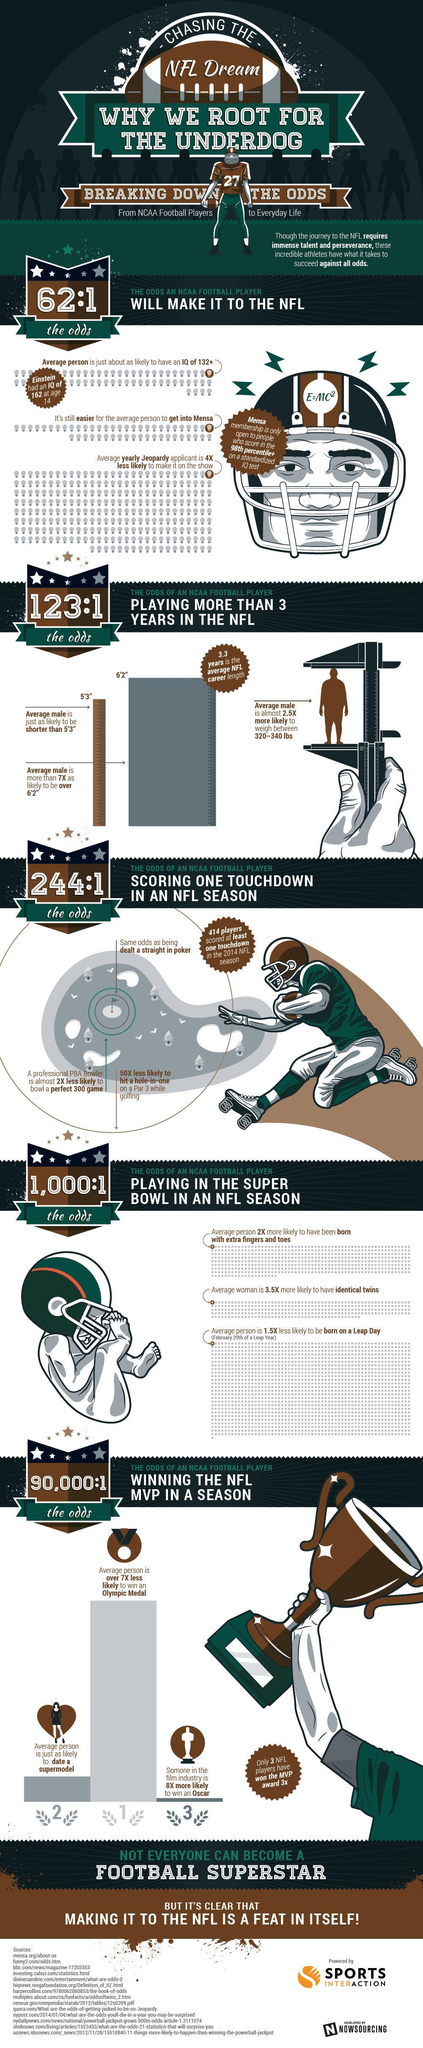How many have won the MVP thrice?
Answer the question with a short phrase. 3 NFL players 